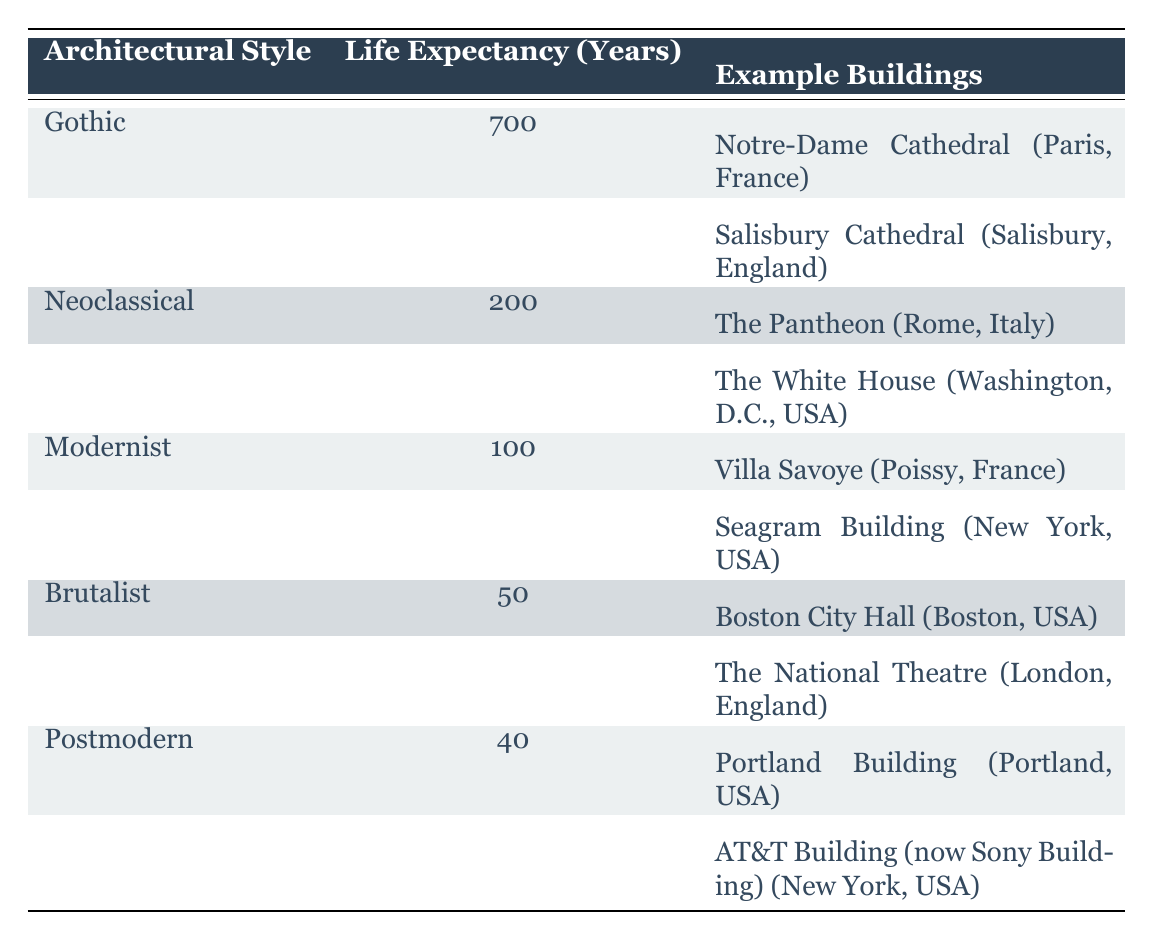What is the life expectancy of the Gothic architectural style? The table lists Gothic under the "Architectural Style" column, showing a life expectancy of 700 years in the corresponding column.
Answer: 700 years Which architectural style has the shortest life expectancy? The table indicates that Postmodern has the shortest life expectancy of 40 years, as seen in the "Life Expectancy (Years)" column.
Answer: Postmodern How many years longer does Gothic architecture last than Modernist architecture? Gothic has a life expectancy of 700 years, while Modernist has 100 years. The difference is 700 - 100 = 600 years.
Answer: 600 years Are there any architectural styles with a life expectancy less than 100 years? Upon reviewing the table, both Brutalist (50 years) and Postmodern (40 years) fall below 100 years, confirming that there are styles that meet this criterion.
Answer: Yes What is the average life expectancy of the architectural styles listed in the table? The total life expectancy can be calculated by adding: 700 + 200 + 100 + 50 + 40 = 1090 years. There are 5 styles, so the average is 1090 / 5 = 218 years.
Answer: 218 years Which architectural style has two example buildings listed? The Gothic style is the only one with two example buildings (Notre-Dame Cathedral and Salisbury Cathedral), as indicated in the "Example Buildings" section.
Answer: Gothic Is the example building "The White House" related to the Neoclassical architectural style? The table shows "The White House" listed as an example building under the Neoclassical style, confirming its relationship.
Answer: Yes How many architectural styles have a life expectancy greater than 100 years? By reviewing the table, Gothic (700), Neoclassical (200), and Modernist (100) all exceed 100 years, totaling three styles with such longevity.
Answer: 3 